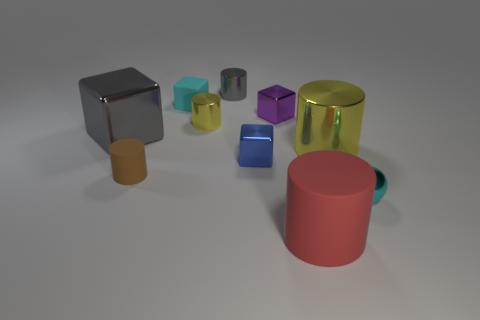Subtract all red cylinders. How many cylinders are left? 4 Subtract all brown cylinders. How many cylinders are left? 4 Subtract 1 blocks. How many blocks are left? 3 Subtract all purple cylinders. Subtract all purple balls. How many cylinders are left? 5 Subtract all balls. How many objects are left? 9 Add 6 small brown rubber cylinders. How many small brown rubber cylinders are left? 7 Add 7 big brown objects. How many big brown objects exist? 7 Subtract 1 gray blocks. How many objects are left? 9 Subtract all brown matte objects. Subtract all tiny gray cylinders. How many objects are left? 8 